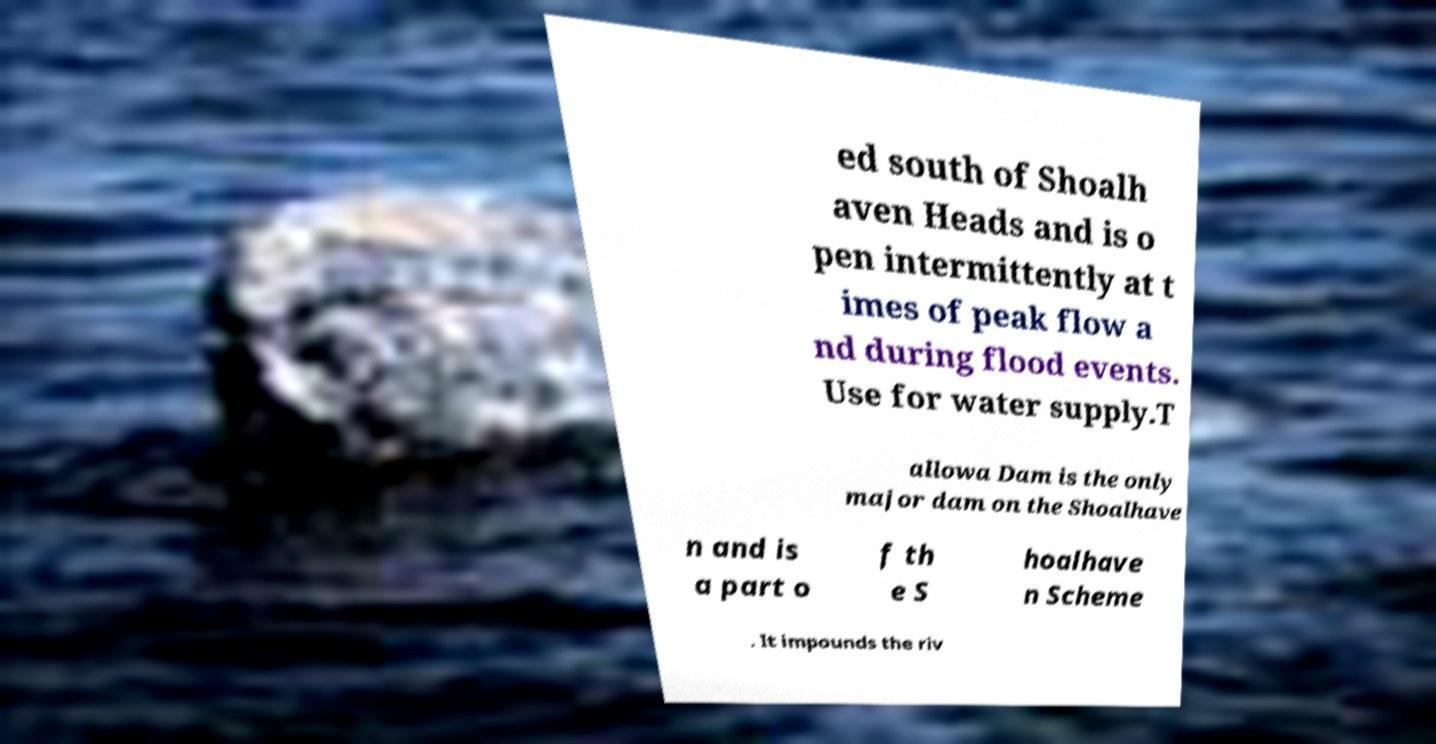Can you accurately transcribe the text from the provided image for me? ed south of Shoalh aven Heads and is o pen intermittently at t imes of peak flow a nd during flood events. Use for water supply.T allowa Dam is the only major dam on the Shoalhave n and is a part o f th e S hoalhave n Scheme . It impounds the riv 